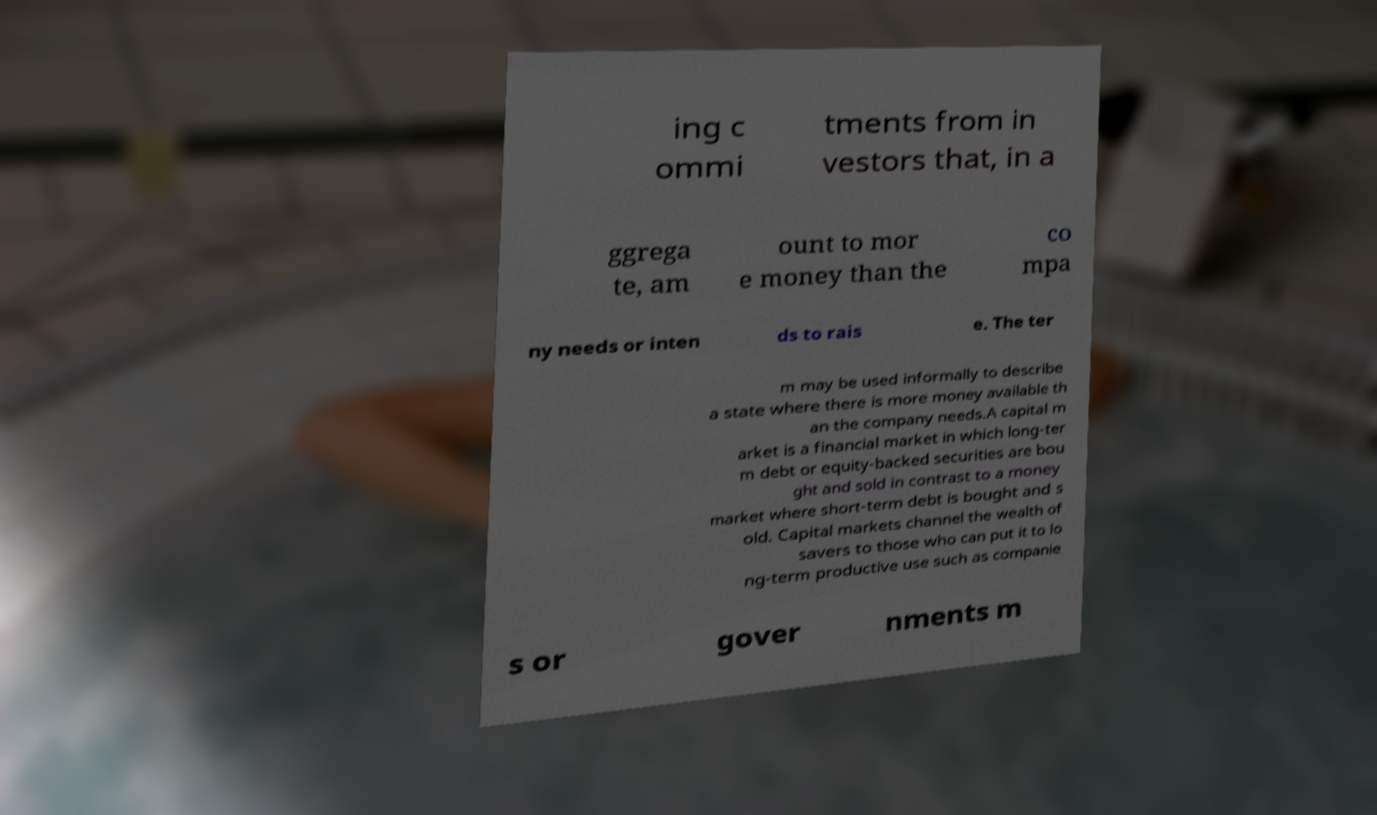I need the written content from this picture converted into text. Can you do that? ing c ommi tments from in vestors that, in a ggrega te, am ount to mor e money than the co mpa ny needs or inten ds to rais e. The ter m may be used informally to describe a state where there is more money available th an the company needs.A capital m arket is a financial market in which long-ter m debt or equity-backed securities are bou ght and sold in contrast to a money market where short-term debt is bought and s old. Capital markets channel the wealth of savers to those who can put it to lo ng-term productive use such as companie s or gover nments m 